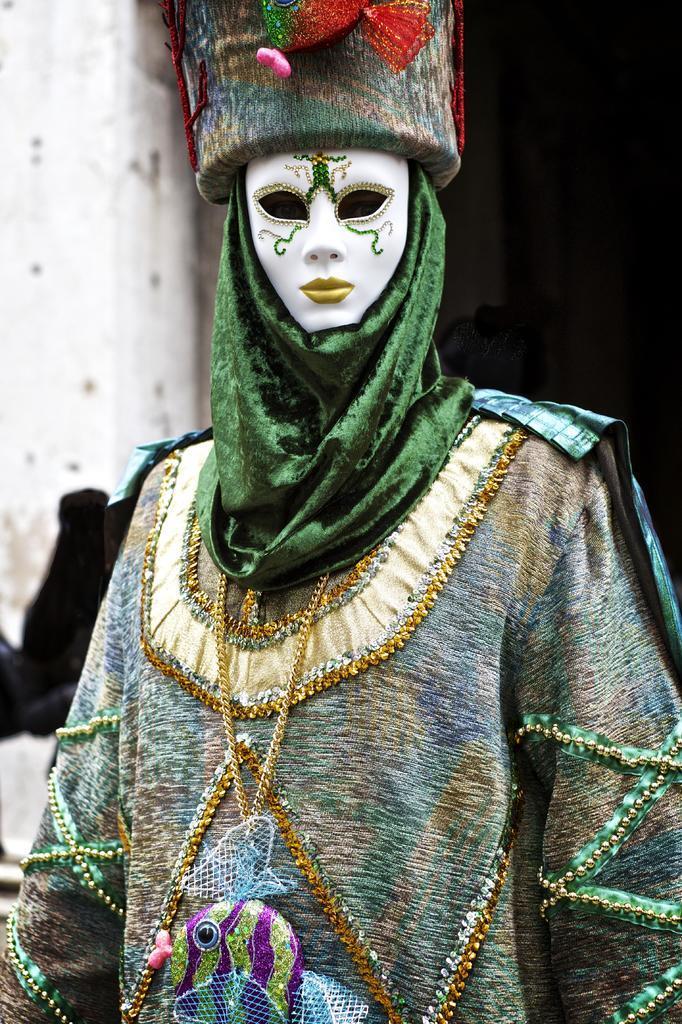Could you give a brief overview of what you see in this image? In this picture we can see a person, the person wore costume and a mask. 